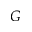<formula> <loc_0><loc_0><loc_500><loc_500>G</formula> 